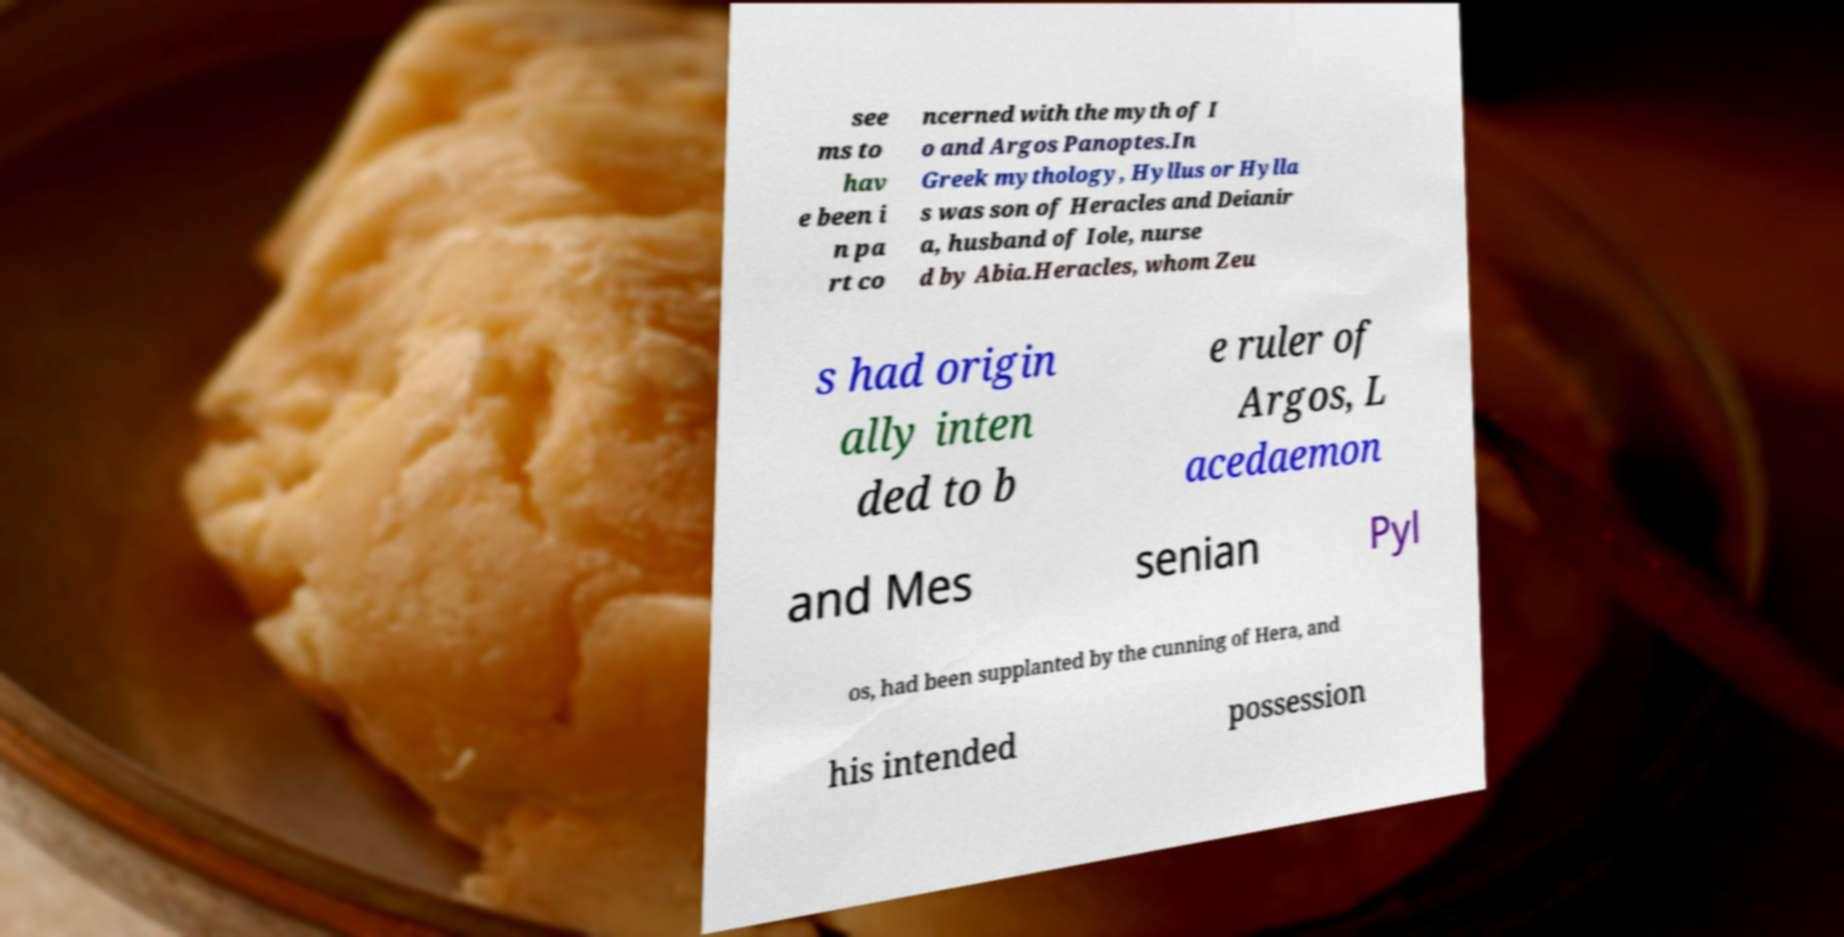What messages or text are displayed in this image? I need them in a readable, typed format. see ms to hav e been i n pa rt co ncerned with the myth of I o and Argos Panoptes.In Greek mythology, Hyllus or Hylla s was son of Heracles and Deianir a, husband of Iole, nurse d by Abia.Heracles, whom Zeu s had origin ally inten ded to b e ruler of Argos, L acedaemon and Mes senian Pyl os, had been supplanted by the cunning of Hera, and his intended possession 